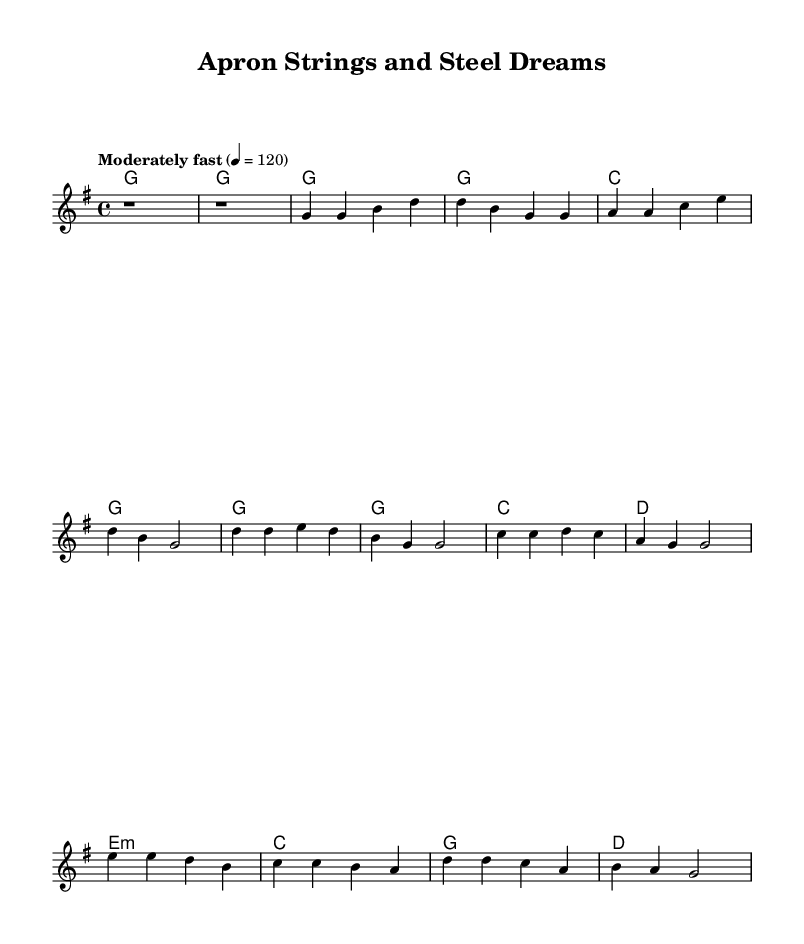what is the key signature of this music? The key signature indicated at the beginning of the sheet music is G major, which contains one sharp (F#).
Answer: G major what is the time signature of the music? The time signature shown at the beginning of the excerpt is 4/4, indicating four beats per measure.
Answer: 4/4 what is the tempo marking of the piece? The tempo marking reads "Moderately fast" with a metronome marking of 120 beats per minute.
Answer: 120 how many measures are in the verse? The verse consists of four measures as seen in the melody section; each measure is represented by a distinct grouping of notes.
Answer: Four measures what chord follows the chorus in the score? The chord progression following the chorus includes a C major chord in the harmonies section, which is consistent with typical country music.
Answer: C what thematic element is celebrated in the lyrics? The lyrics emphasize the hard work and dedication of a diner girl, portraying empowerment through her service and effort in the diner setting.
Answer: Empowerment how does the bridge transition musically? The bridge introduces an E minor chord, which provides contrast from the previous sections, creating a reflective moment that ties back into the song's message about hard work.
Answer: E minor 